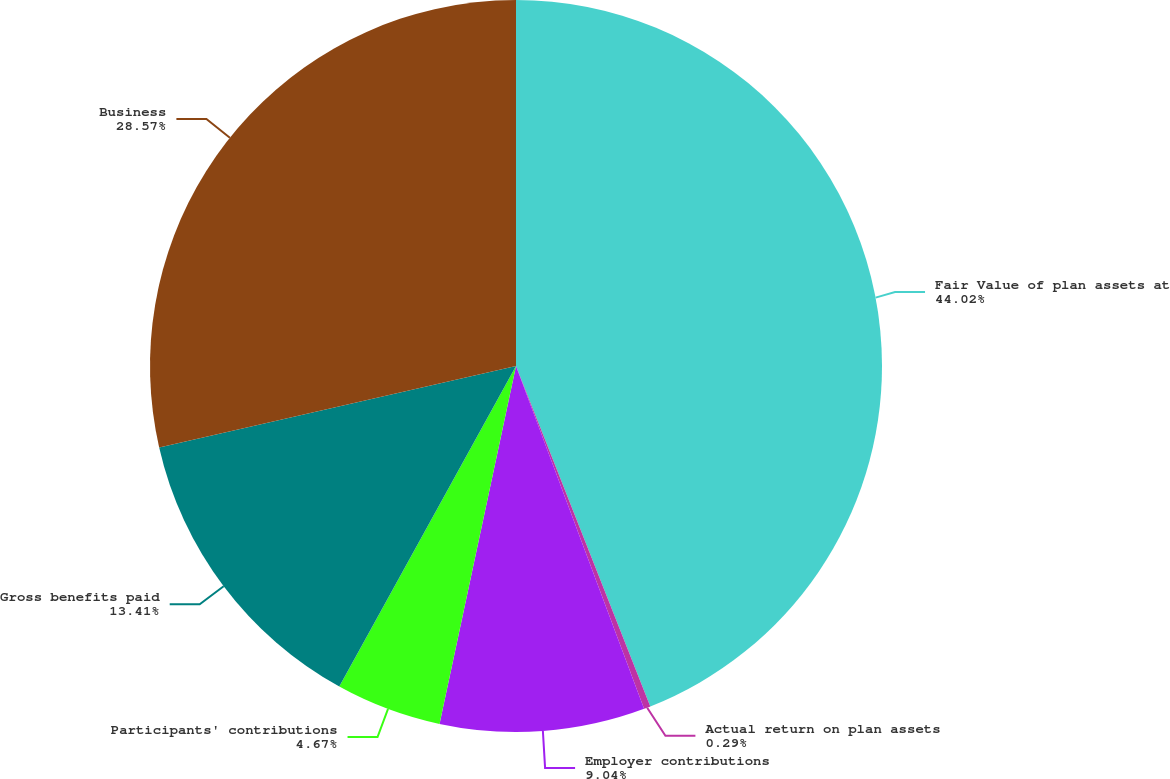Convert chart. <chart><loc_0><loc_0><loc_500><loc_500><pie_chart><fcel>Fair Value of plan assets at<fcel>Actual return on plan assets<fcel>Employer contributions<fcel>Participants' contributions<fcel>Gross benefits paid<fcel>Business<nl><fcel>44.02%<fcel>0.29%<fcel>9.04%<fcel>4.67%<fcel>13.41%<fcel>28.57%<nl></chart> 